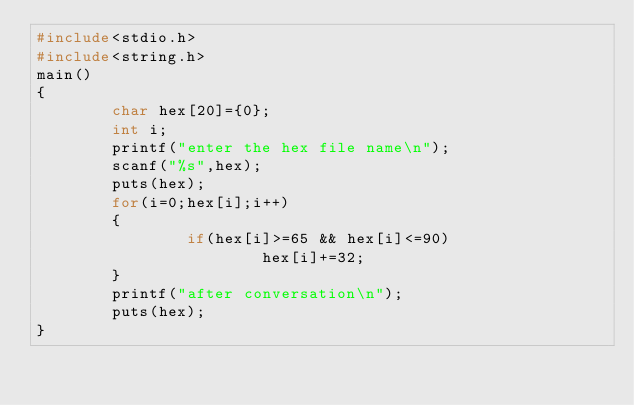<code> <loc_0><loc_0><loc_500><loc_500><_C_>#include<stdio.h>
#include<string.h>
main()
{
        char hex[20]={0};
        int i;
        printf("enter the hex file name\n");
        scanf("%s",hex);
        puts(hex);
        for(i=0;hex[i];i++)
        {
                if(hex[i]>=65 && hex[i]<=90)
                        hex[i]+=32;
        }
        printf("after conversation\n");
        puts(hex);
}

</code> 